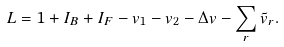<formula> <loc_0><loc_0><loc_500><loc_500>L = 1 + I _ { B } + I _ { F } - v _ { 1 } - v _ { 2 } - \Delta v - \sum _ { r } \tilde { v } _ { r } .</formula> 